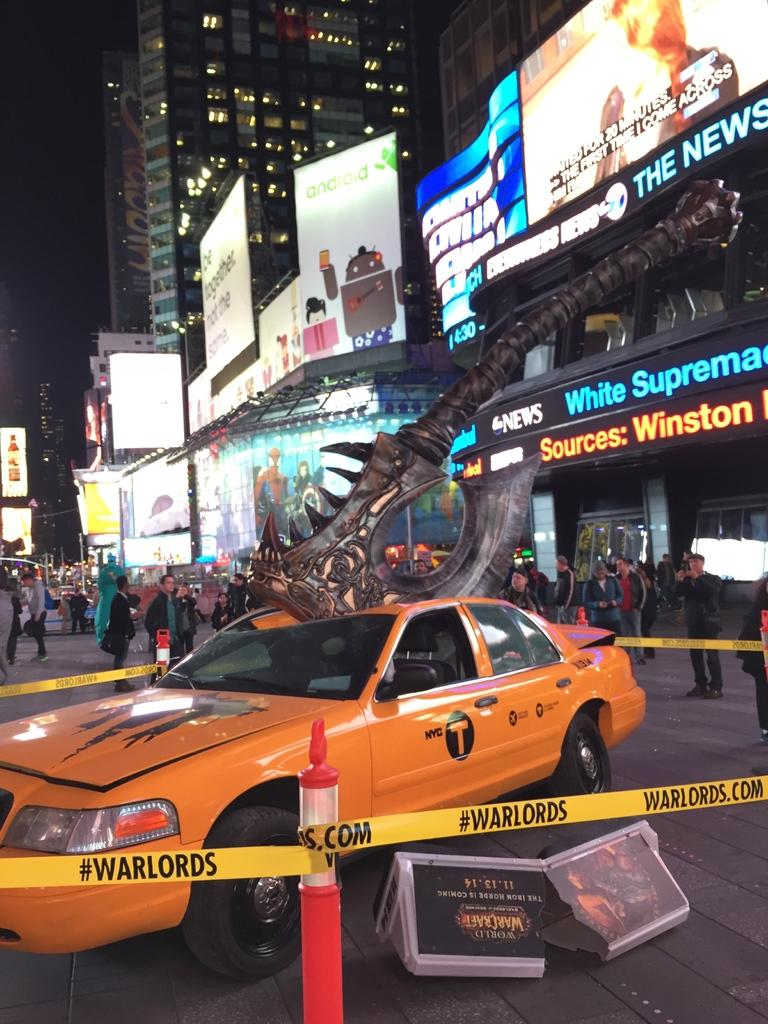<image>
Create a compact narrative representing the image presented. Yellow caution tape surrounding a cab reads warlords. 